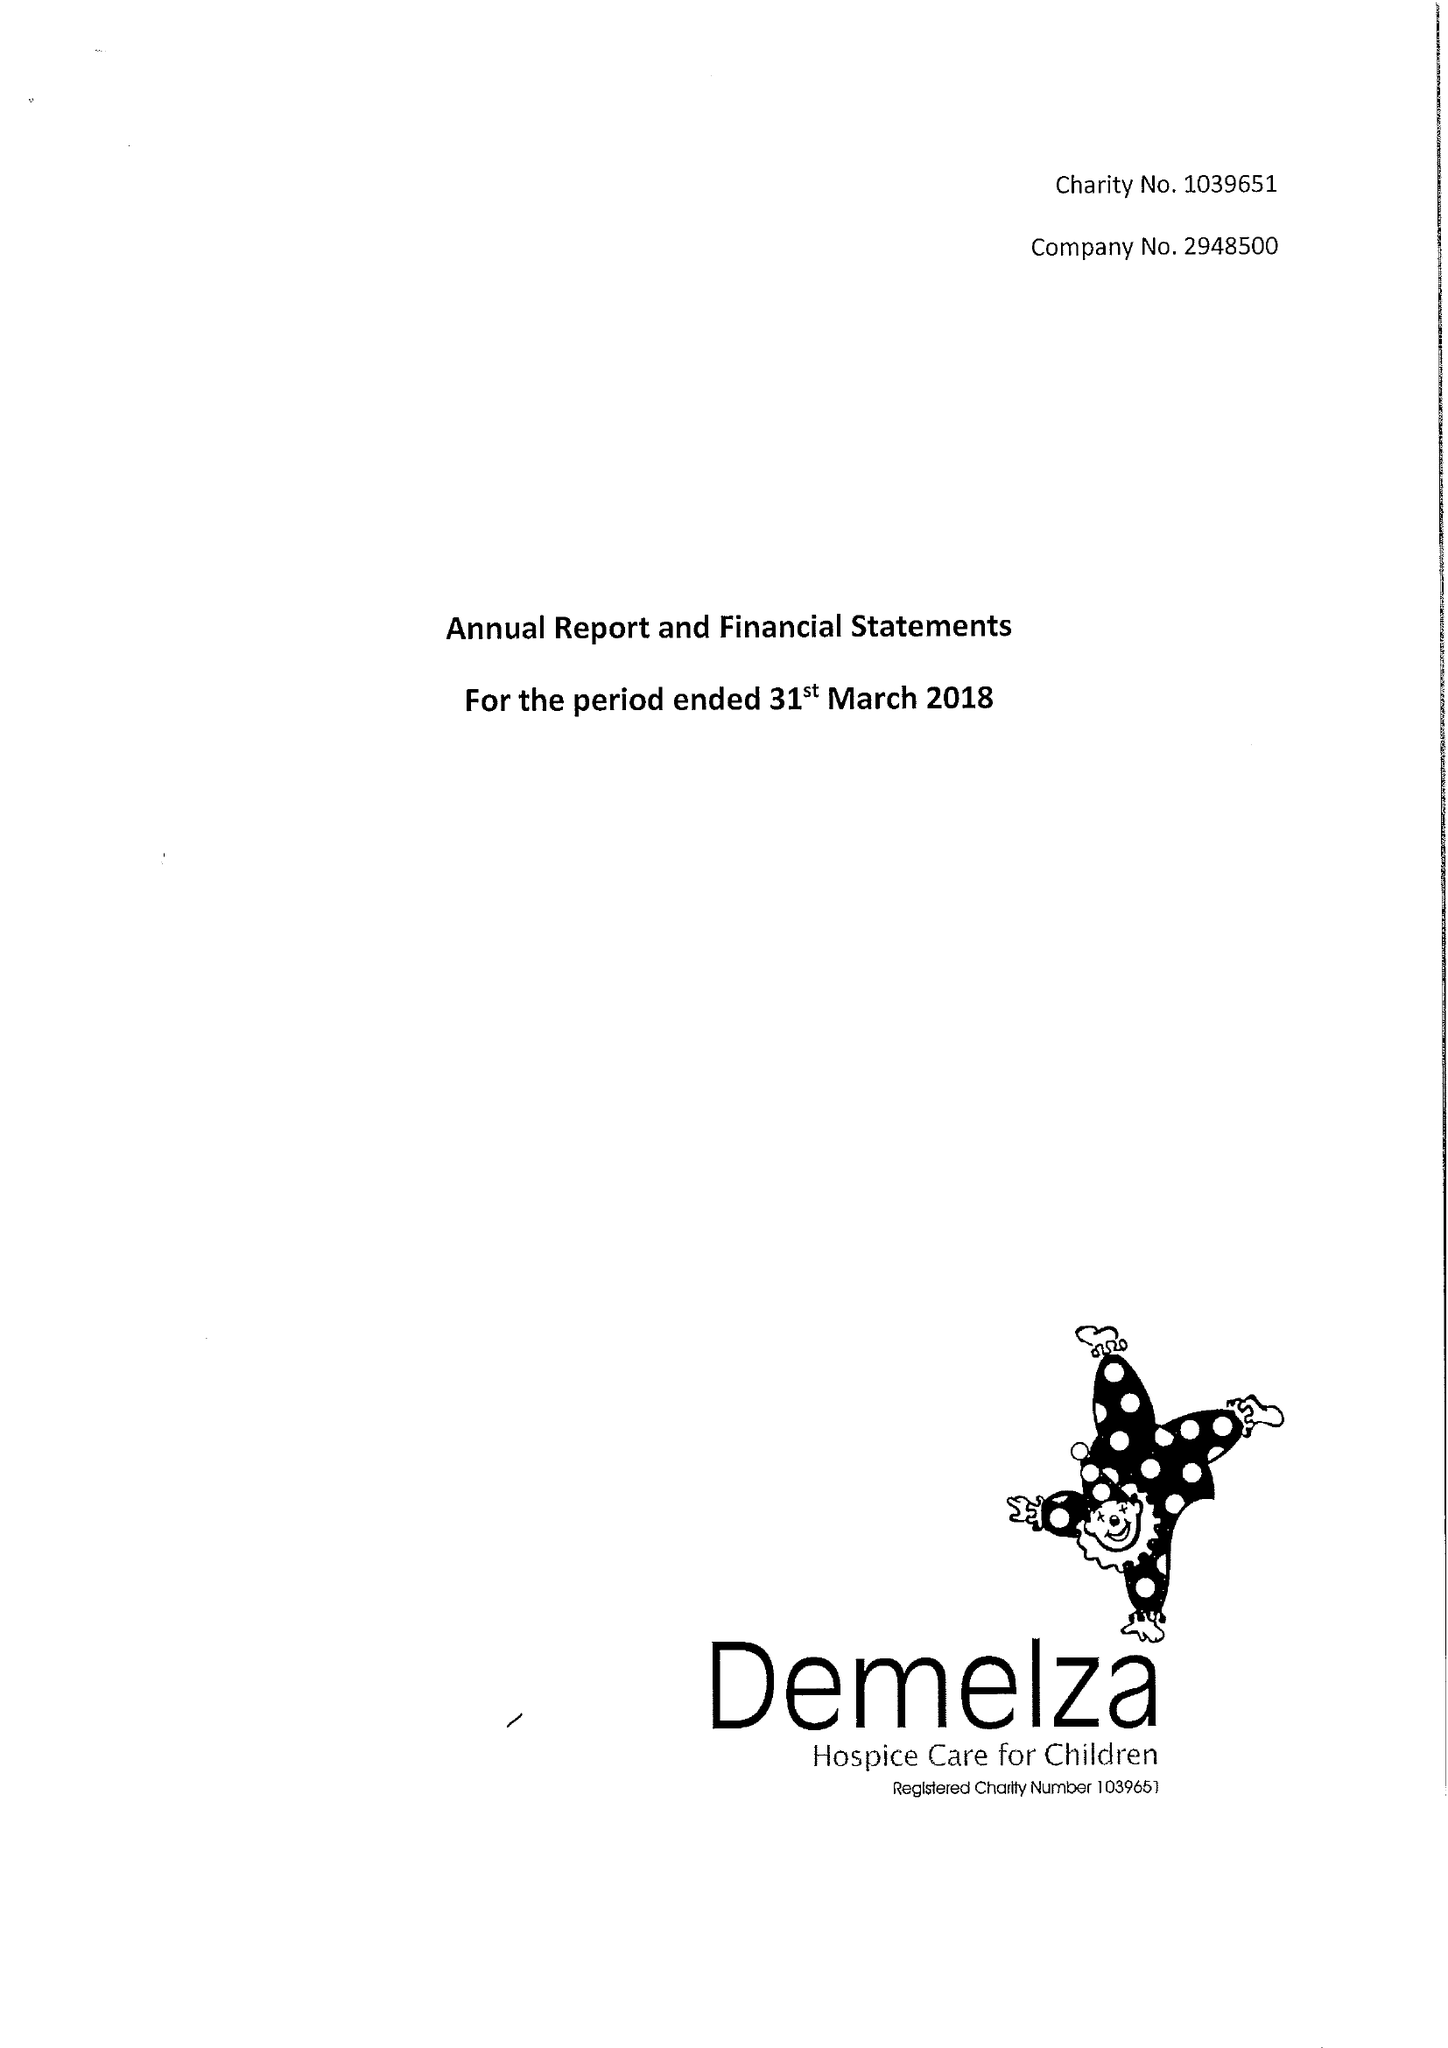What is the value for the address__post_town?
Answer the question using a single word or phrase. SITTINGBOURNE 